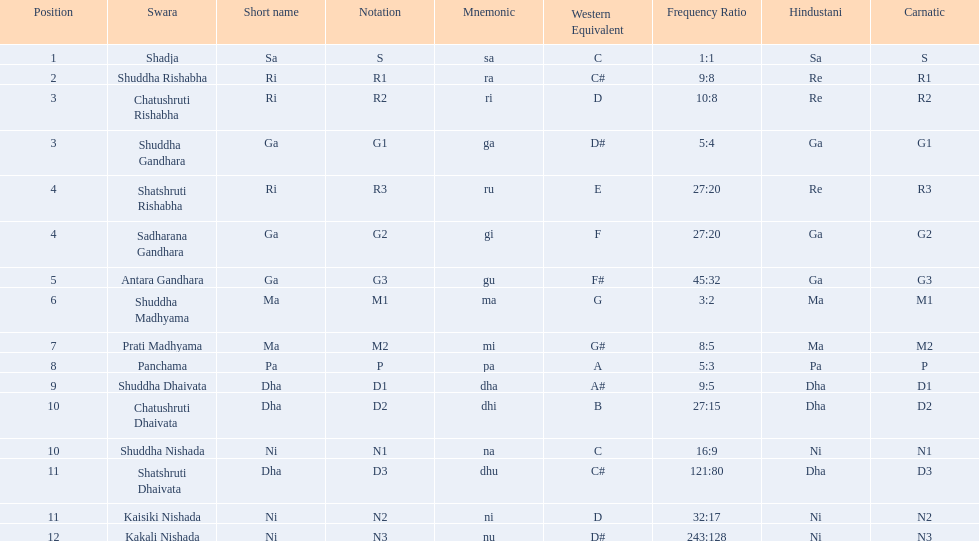List each pair of swaras that share the same position. Chatushruti Rishabha, Shuddha Gandhara, Shatshruti Rishabha, Sadharana Gandhara, Chatushruti Dhaivata, Shuddha Nishada, Shatshruti Dhaivata, Kaisiki Nishada. 